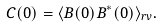<formula> <loc_0><loc_0><loc_500><loc_500>C ( 0 ) = \langle B ( 0 ) B ^ { * } ( 0 ) \rangle _ { r v } .</formula> 